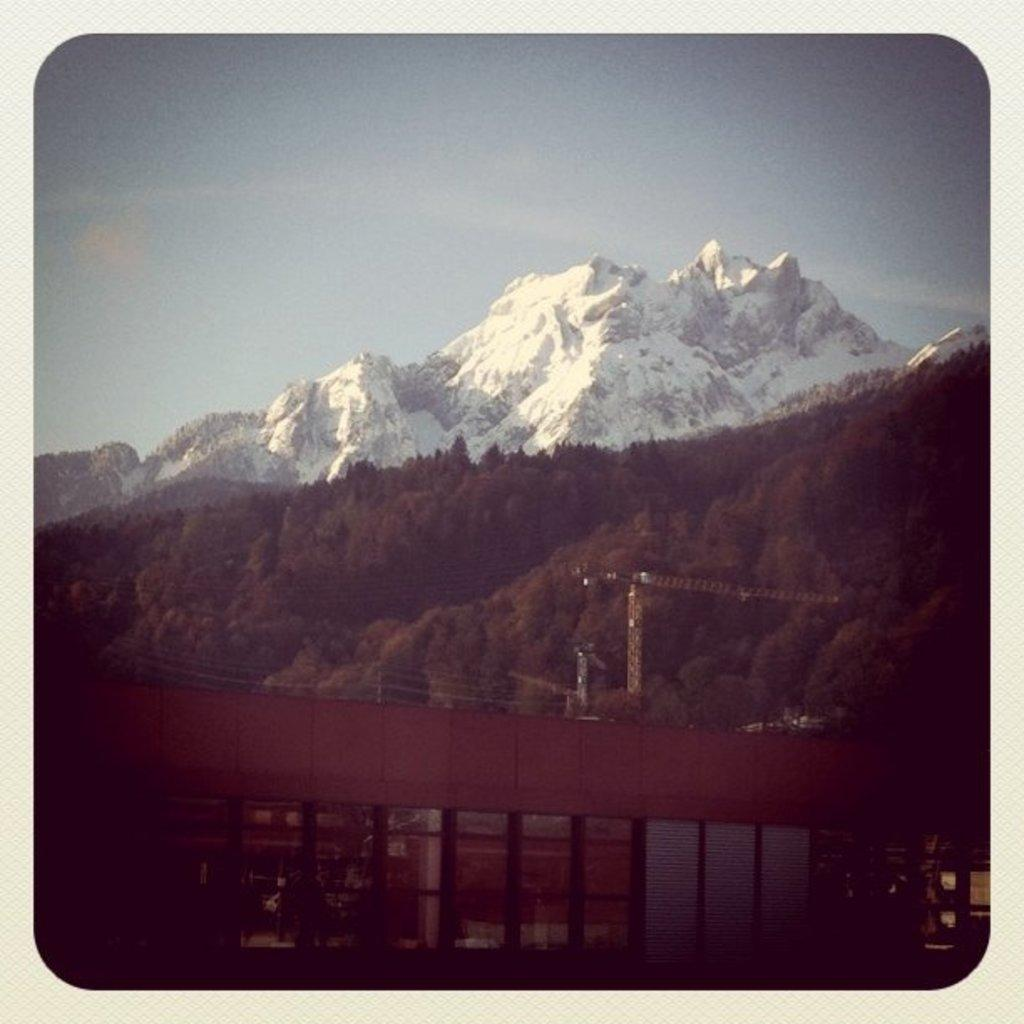What type of landform can be seen on the left side of the image? There is a hill in the image. What other type of landform is present in the image? There is a mountain in the image. What is visible at the top of the image? The sky is visible at the top of the image. What structure can be seen in the middle of the image? There is a bridge in the middle of the image. How many feet are visible on the bridge in the image? There are no feet visible on the bridge in the image. What type of impulse can be seen affecting the mountain in the image? There is no impulse affecting the mountain in the image; it is a static landform. 